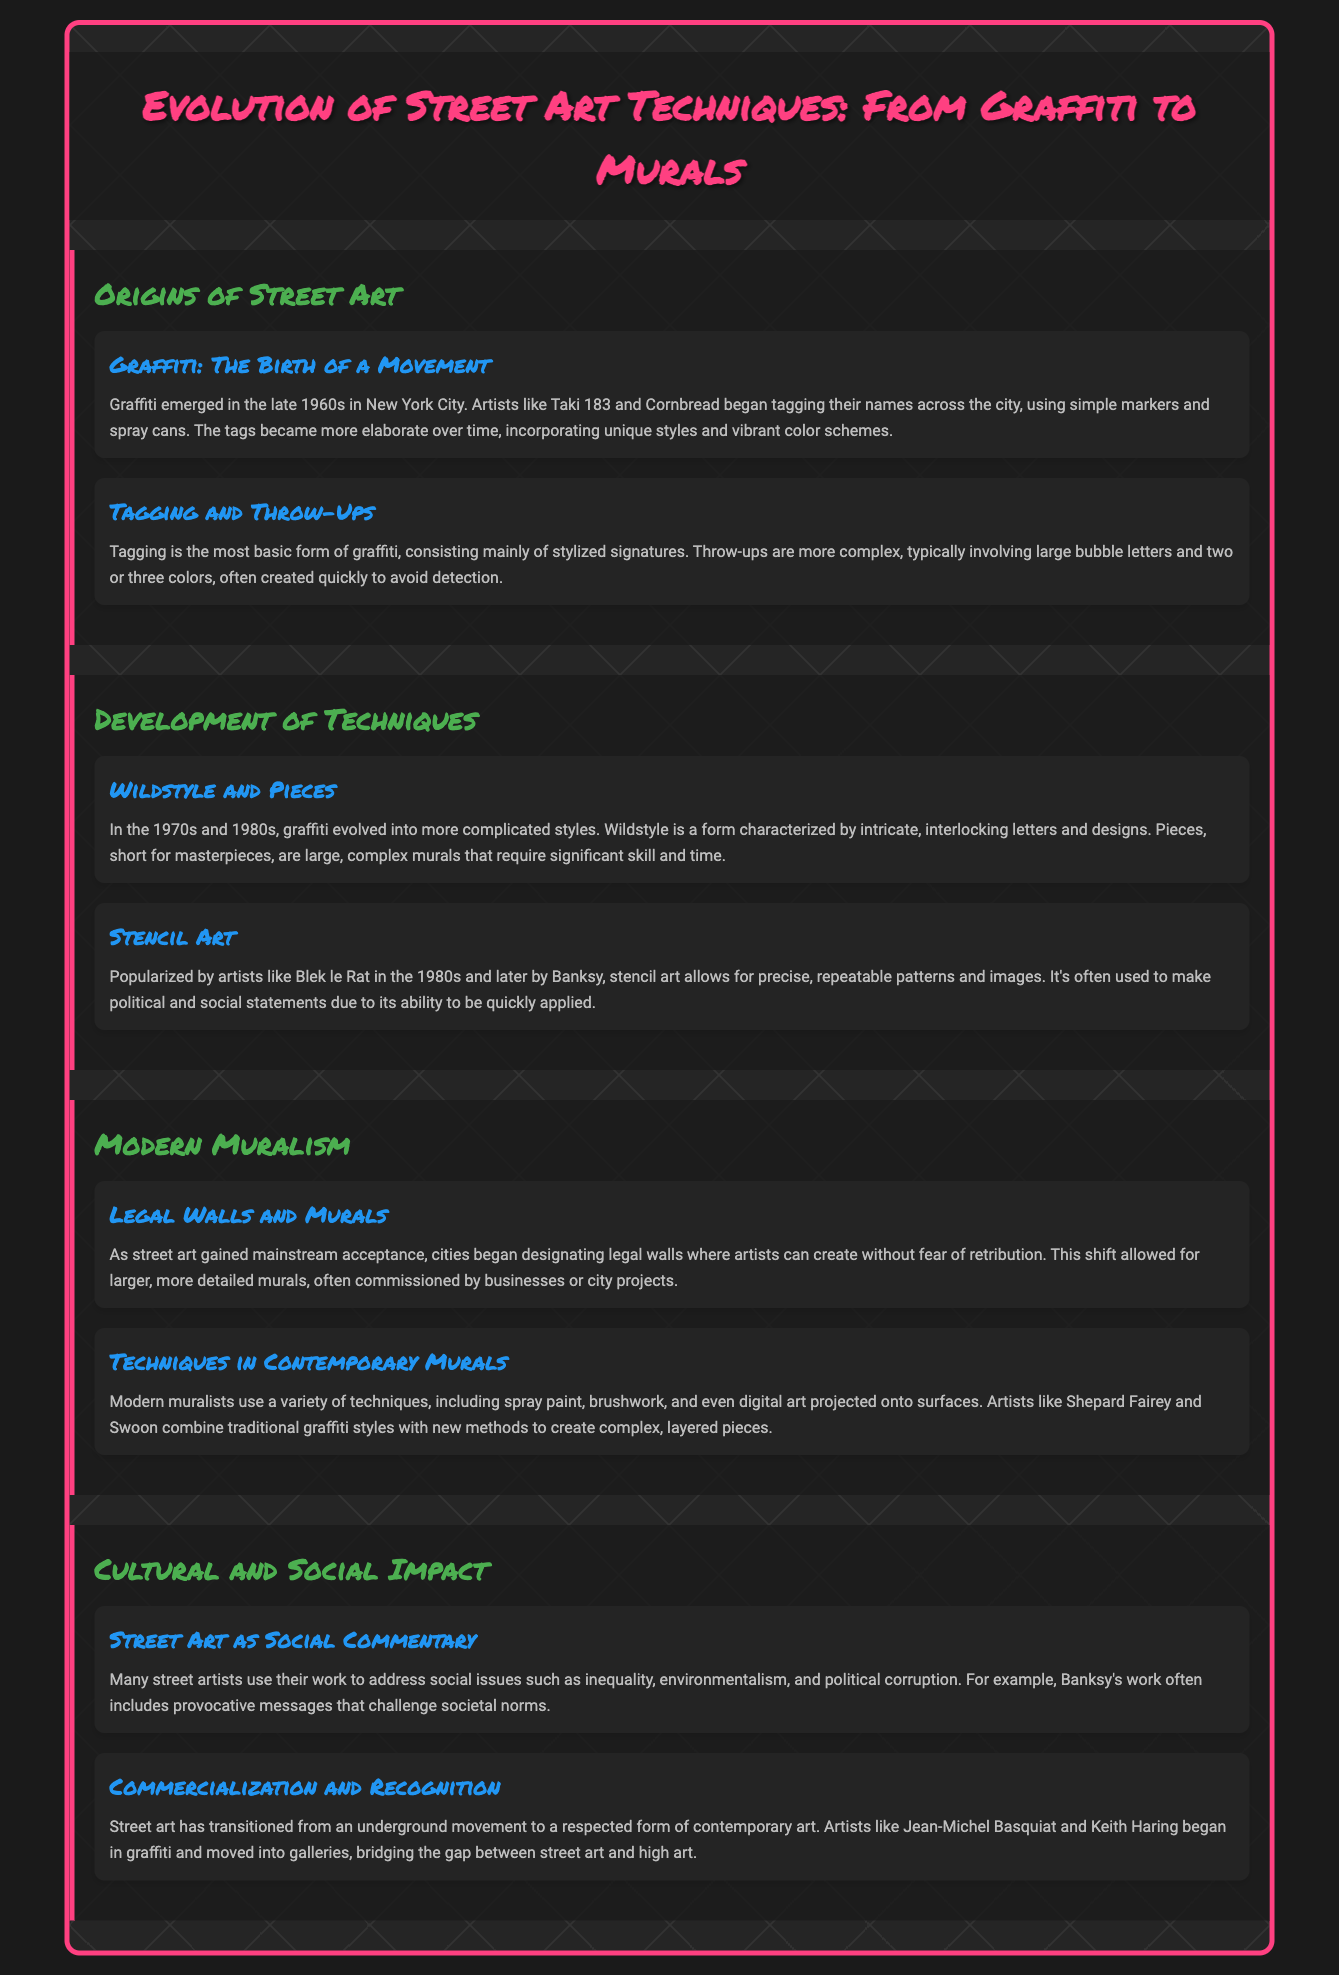what year did graffiti emerge in New York City? The document states that graffiti emerged in the late 1960s in New York City.
Answer: late 1960s who is highlighted as popularizing stencil art in the 1980s? The document mentions Blek le Rat as a key figure in popularizing stencil art during the 1980s.
Answer: Blek le Rat what are "legal walls" in the context of modern muralism? Legal walls are designated areas where artists can create street art without the fear of retribution, according to the document.
Answer: designated areas which term describes intricate, interlocking letters in graffiti? The term used in the document to describe these letters is "Wildstyle."
Answer: Wildstyle how did street art transition according to the document? The document explains that street art transitioned from an underground movement to a respected form of contemporary art.
Answer: from underground to respected art what is a "piece" short for in graffiti terminology? The document clarifies that the term "pieces" is short for masterpieces.
Answer: masterpieces what social issues do many street artists address in their work? According to the document, street artists often address issues such as inequality, environmentalism, and political corruption.
Answer: inequality, environmentalism, and political corruption who are two artists mentioned that bridged the gap between street art and high art? The artists mentioned for this transition are Jean-Michel Basquiat and Keith Haring.
Answer: Jean-Michel Basquiat and Keith Haring 